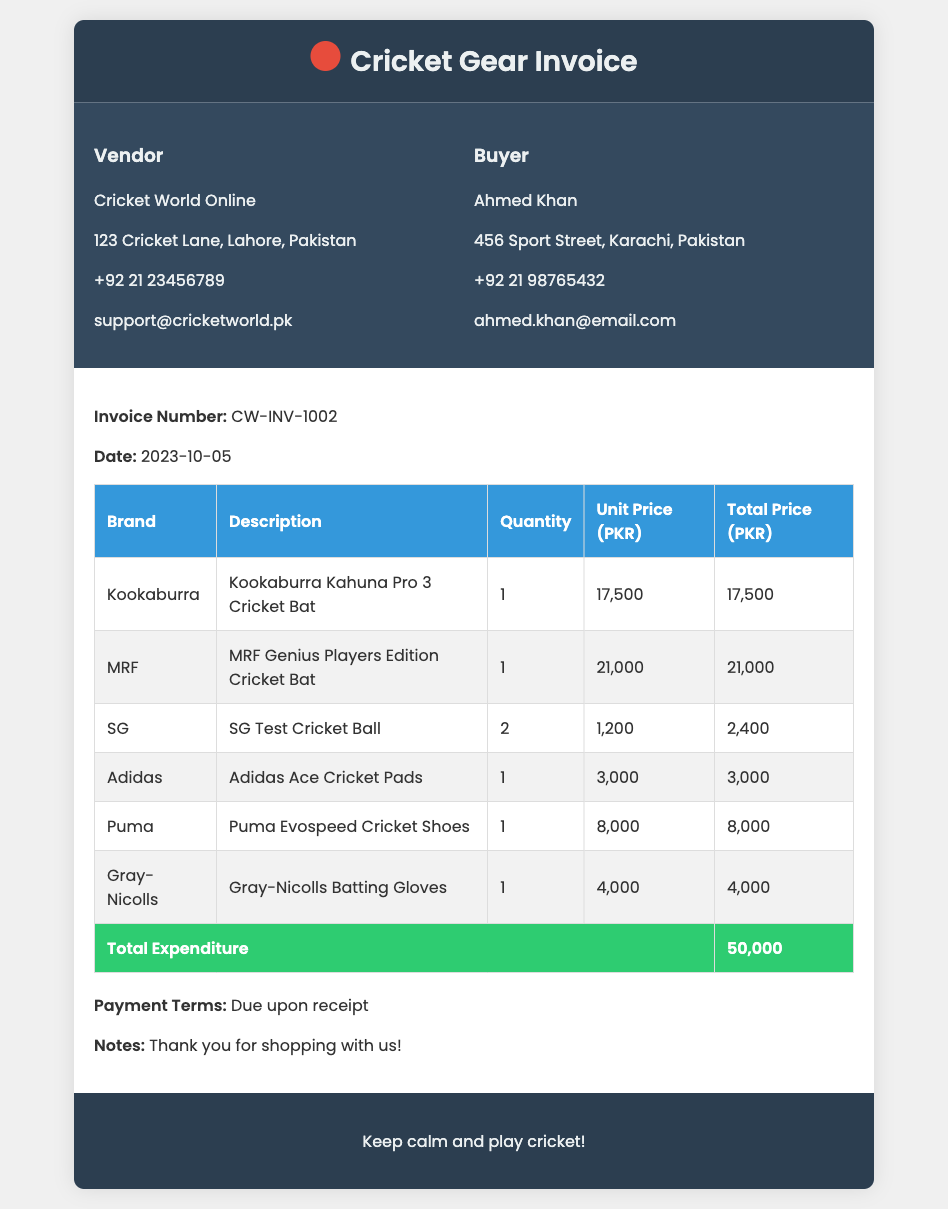What is the invoice number? The invoice number is listed in the document under the invoice details section.
Answer: CW-INV-1002 What is the total expenditure? The total expenditure is shown in the table as the total price summary.
Answer: 50,000 What is the brand of the first item purchased? The brand for the first item listed in the invoice is provided in the table under the Brand column.
Answer: Kookaburra How many SG Test Cricket Balls were purchased? The quantity of SG Test Cricket Balls is specified in the table.
Answer: 2 What are the payment terms indicated in the invoice? The payment terms are mentioned in the body of the invoice.
Answer: Due upon receipt Which cricket bat has the highest unit price? To find this, one must compare the unit prices listed in the table.
Answer: MRF Genius Players Edition Cricket Bat Who is the buyer listed on the invoice? The buyer's details are found in the buyer details section.
Answer: Ahmed Khan What is the date of the invoice? The date is stated in the invoice details section.
Answer: 2023-10-05 What is the address of the vendor? The vendor's address is given in the vendor details section.
Answer: 123 Cricket Lane, Lahore, Pakistan 